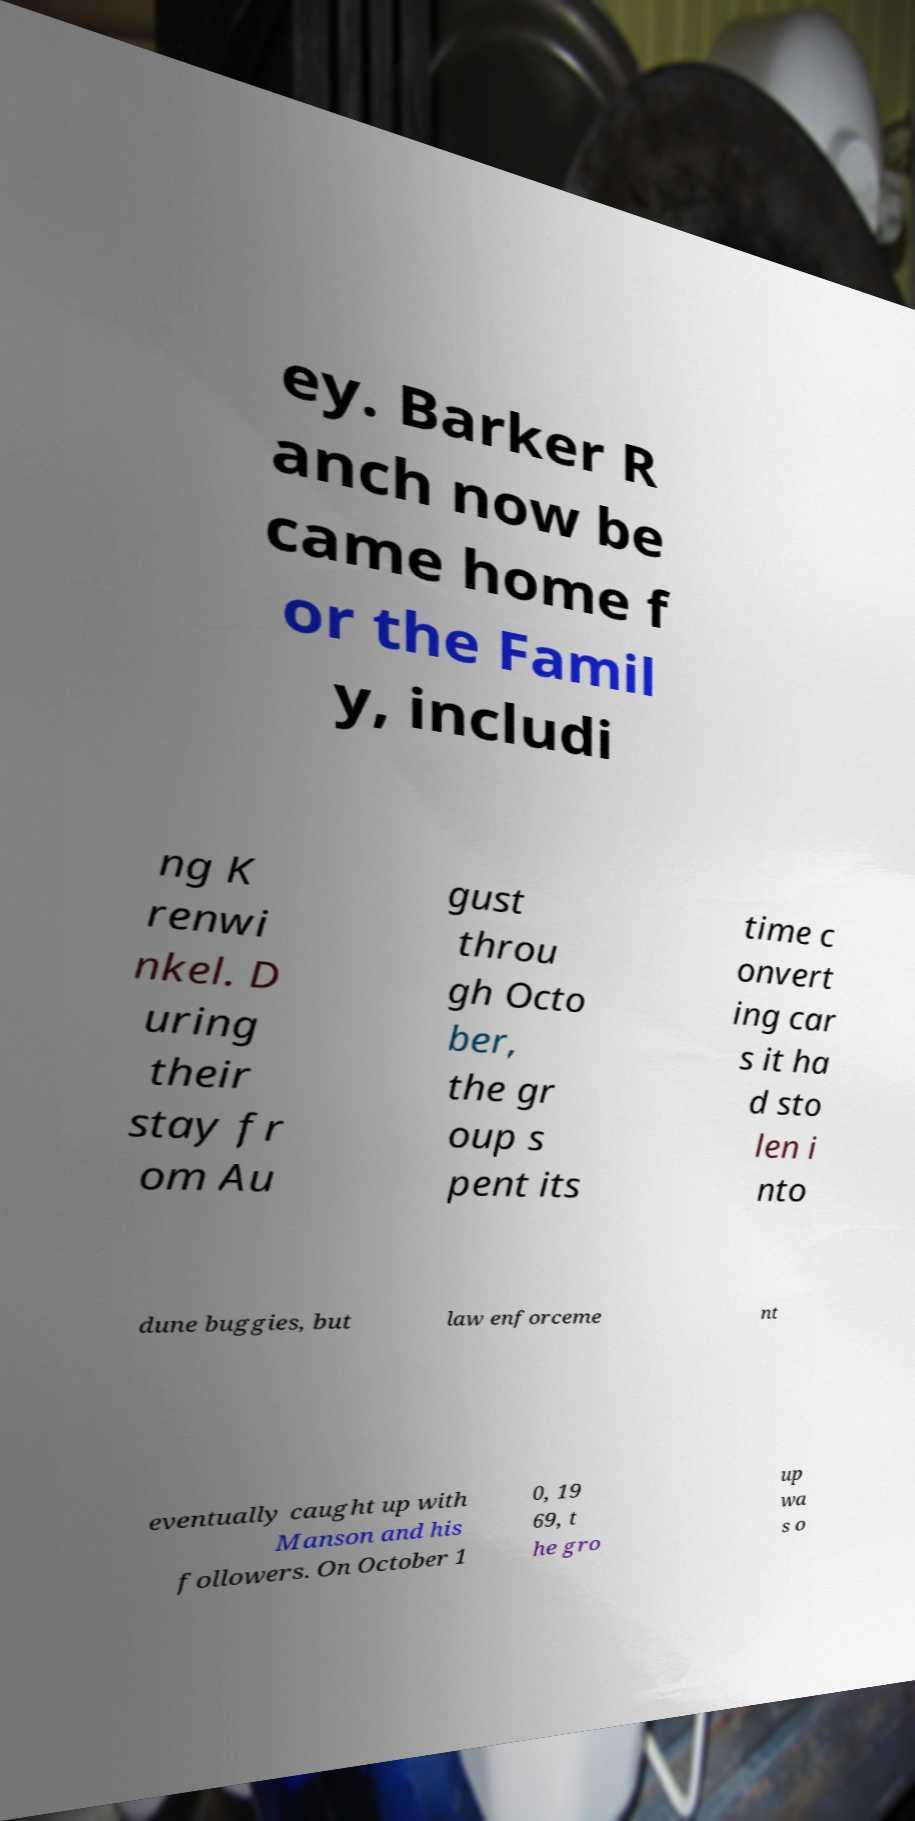What messages or text are displayed in this image? I need them in a readable, typed format. ey. Barker R anch now be came home f or the Famil y, includi ng K renwi nkel. D uring their stay fr om Au gust throu gh Octo ber, the gr oup s pent its time c onvert ing car s it ha d sto len i nto dune buggies, but law enforceme nt eventually caught up with Manson and his followers. On October 1 0, 19 69, t he gro up wa s o 